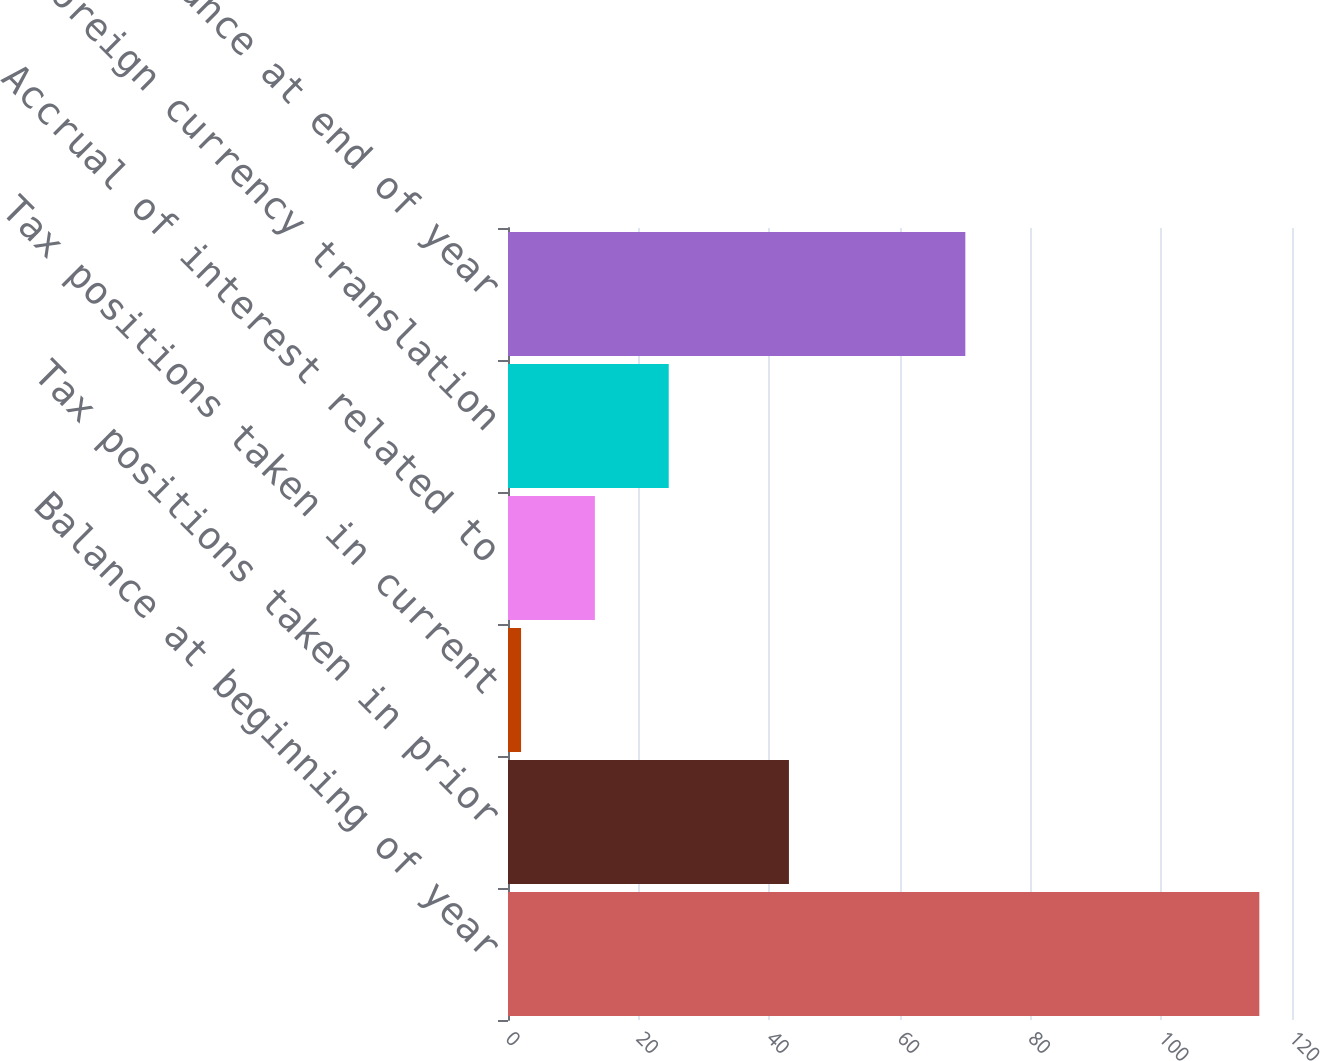Convert chart to OTSL. <chart><loc_0><loc_0><loc_500><loc_500><bar_chart><fcel>Balance at beginning of year<fcel>Tax positions taken in prior<fcel>Tax positions taken in current<fcel>Accrual of interest related to<fcel>Foreign currency translation<fcel>Balance at end of year<nl><fcel>115<fcel>43<fcel>2<fcel>13.3<fcel>24.6<fcel>70<nl></chart> 